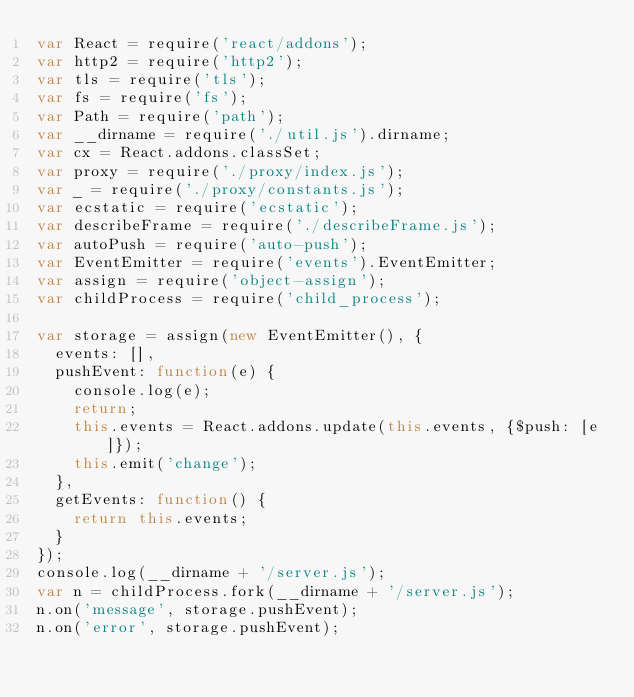Convert code to text. <code><loc_0><loc_0><loc_500><loc_500><_JavaScript_>var React = require('react/addons');
var http2 = require('http2');
var tls = require('tls');
var fs = require('fs');
var Path = require('path');
var __dirname = require('./util.js').dirname;
var cx = React.addons.classSet;
var proxy = require('./proxy/index.js');
var _ = require('./proxy/constants.js');
var ecstatic = require('ecstatic');
var describeFrame = require('./describeFrame.js');
var autoPush = require('auto-push');
var EventEmitter = require('events').EventEmitter;
var assign = require('object-assign');
var childProcess = require('child_process');

var storage = assign(new EventEmitter(), {
  events: [],
  pushEvent: function(e) {
    console.log(e);
    return;
    this.events = React.addons.update(this.events, {$push: [e]});
    this.emit('change');
  },
  getEvents: function() {
    return this.events;
  }
});
console.log(__dirname + '/server.js');
var n = childProcess.fork(__dirname + '/server.js');
n.on('message', storage.pushEvent);
n.on('error', storage.pushEvent);</code> 